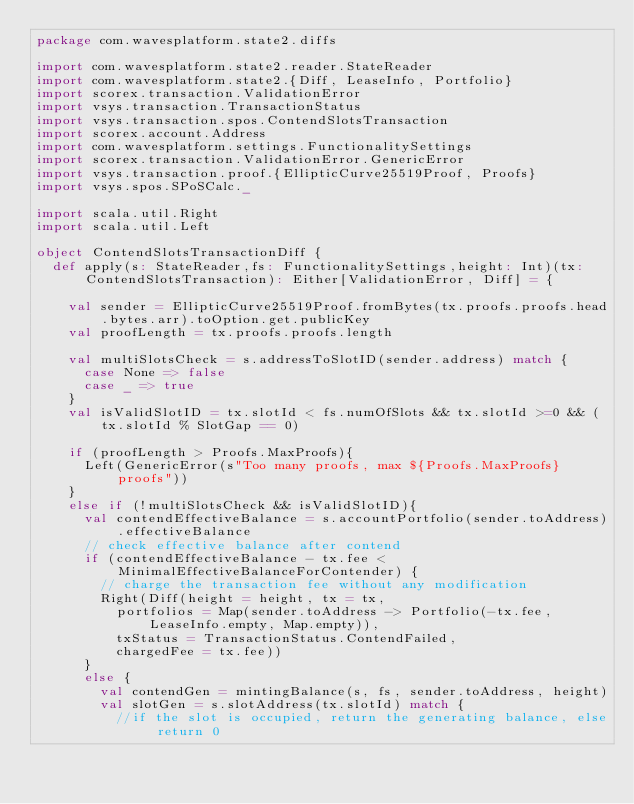Convert code to text. <code><loc_0><loc_0><loc_500><loc_500><_Scala_>package com.wavesplatform.state2.diffs

import com.wavesplatform.state2.reader.StateReader
import com.wavesplatform.state2.{Diff, LeaseInfo, Portfolio}
import scorex.transaction.ValidationError
import vsys.transaction.TransactionStatus
import vsys.transaction.spos.ContendSlotsTransaction
import scorex.account.Address
import com.wavesplatform.settings.FunctionalitySettings
import scorex.transaction.ValidationError.GenericError
import vsys.transaction.proof.{EllipticCurve25519Proof, Proofs}
import vsys.spos.SPoSCalc._

import scala.util.Right
import scala.util.Left

object ContendSlotsTransactionDiff {
  def apply(s: StateReader,fs: FunctionalitySettings,height: Int)(tx: ContendSlotsTransaction): Either[ValidationError, Diff] = {

    val sender = EllipticCurve25519Proof.fromBytes(tx.proofs.proofs.head.bytes.arr).toOption.get.publicKey
    val proofLength = tx.proofs.proofs.length

    val multiSlotsCheck = s.addressToSlotID(sender.address) match {
      case None => false
      case _ => true
    }
    val isValidSlotID = tx.slotId < fs.numOfSlots && tx.slotId >=0 && (tx.slotId % SlotGap == 0)

    if (proofLength > Proofs.MaxProofs){
      Left(GenericError(s"Too many proofs, max ${Proofs.MaxProofs} proofs"))
    }
    else if (!multiSlotsCheck && isValidSlotID){
      val contendEffectiveBalance = s.accountPortfolio(sender.toAddress).effectiveBalance
      // check effective balance after contend
      if (contendEffectiveBalance - tx.fee < MinimalEffectiveBalanceForContender) {
        // charge the transaction fee without any modification
        Right(Diff(height = height, tx = tx,
          portfolios = Map(sender.toAddress -> Portfolio(-tx.fee, LeaseInfo.empty, Map.empty)),
          txStatus = TransactionStatus.ContendFailed,
          chargedFee = tx.fee))
      }
      else {
        val contendGen = mintingBalance(s, fs, sender.toAddress, height)
        val slotGen = s.slotAddress(tx.slotId) match {
          //if the slot is occupied, return the generating balance, else return 0</code> 